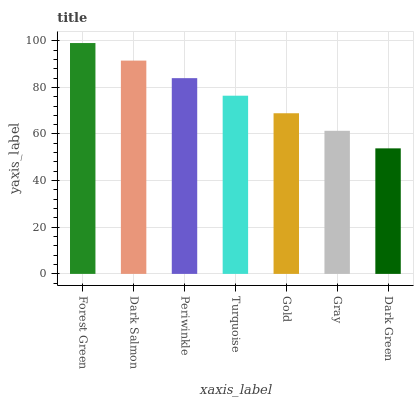Is Dark Green the minimum?
Answer yes or no. Yes. Is Forest Green the maximum?
Answer yes or no. Yes. Is Dark Salmon the minimum?
Answer yes or no. No. Is Dark Salmon the maximum?
Answer yes or no. No. Is Forest Green greater than Dark Salmon?
Answer yes or no. Yes. Is Dark Salmon less than Forest Green?
Answer yes or no. Yes. Is Dark Salmon greater than Forest Green?
Answer yes or no. No. Is Forest Green less than Dark Salmon?
Answer yes or no. No. Is Turquoise the high median?
Answer yes or no. Yes. Is Turquoise the low median?
Answer yes or no. Yes. Is Dark Salmon the high median?
Answer yes or no. No. Is Dark Salmon the low median?
Answer yes or no. No. 